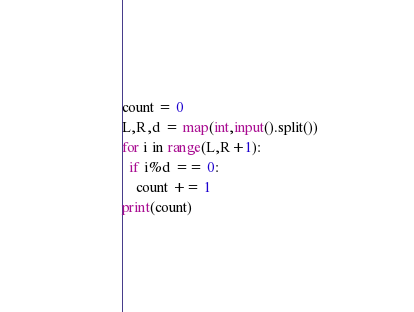<code> <loc_0><loc_0><loc_500><loc_500><_Python_>count = 0
L,R,d = map(int,input().split())
for i in range(L,R+1):
  if i%d == 0:
    count += 1
print(count)</code> 